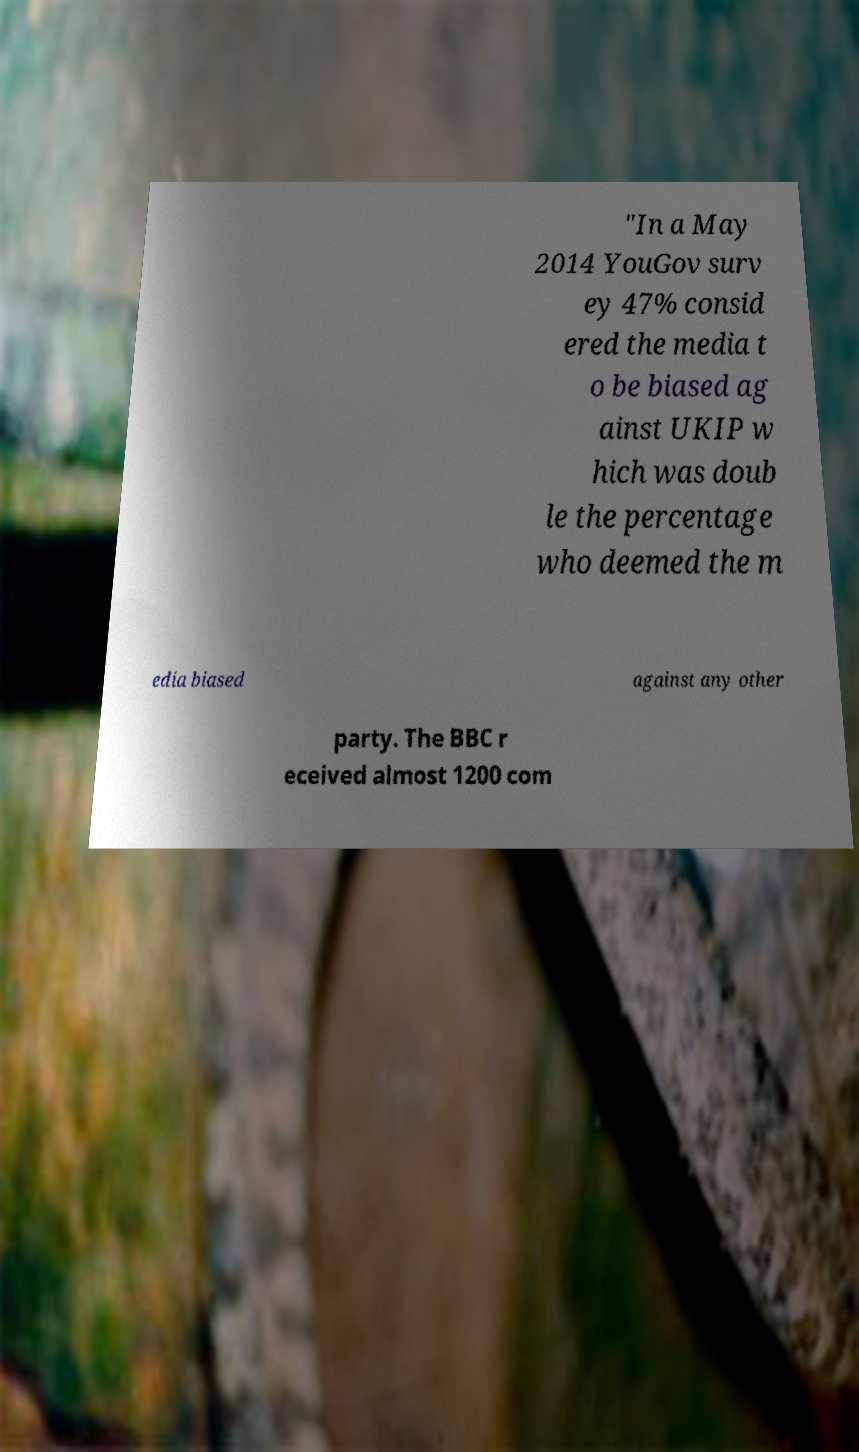Could you extract and type out the text from this image? "In a May 2014 YouGov surv ey 47% consid ered the media t o be biased ag ainst UKIP w hich was doub le the percentage who deemed the m edia biased against any other party. The BBC r eceived almost 1200 com 